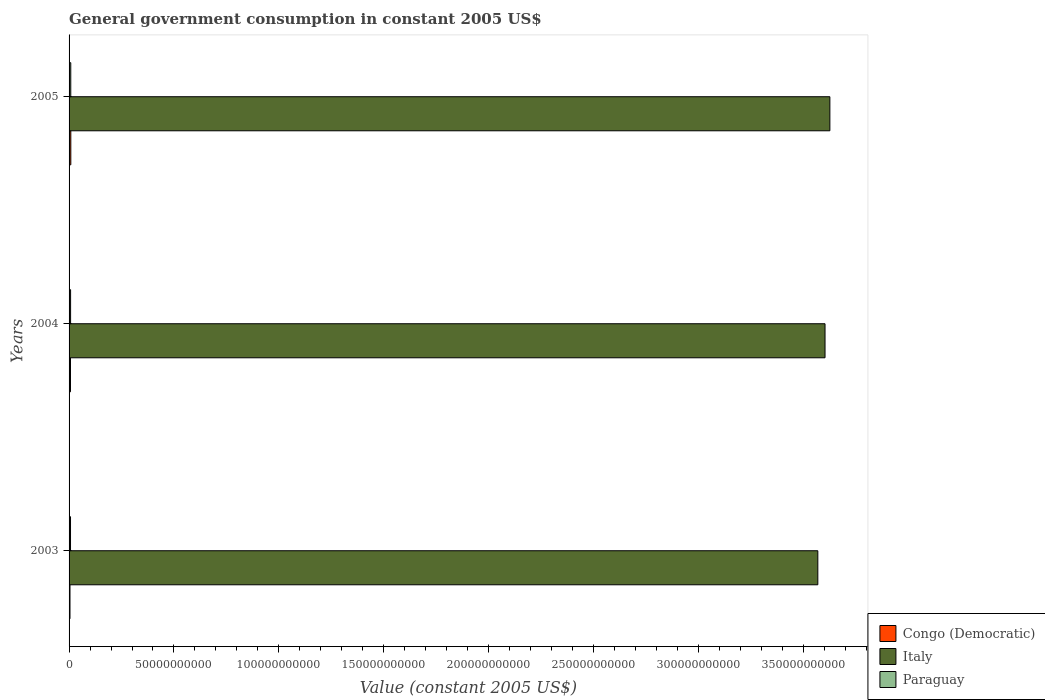What is the government conusmption in Congo (Democratic) in 2004?
Give a very brief answer. 6.73e+08. Across all years, what is the maximum government conusmption in Paraguay?
Your answer should be very brief. 8.11e+08. Across all years, what is the minimum government conusmption in Italy?
Ensure brevity in your answer.  3.57e+11. In which year was the government conusmption in Italy minimum?
Give a very brief answer. 2003. What is the total government conusmption in Congo (Democratic) in the graph?
Your response must be concise. 1.94e+09. What is the difference between the government conusmption in Congo (Democratic) in 2004 and that in 2005?
Ensure brevity in your answer.  -1.58e+08. What is the difference between the government conusmption in Congo (Democratic) in 2004 and the government conusmption in Paraguay in 2005?
Ensure brevity in your answer.  -1.38e+08. What is the average government conusmption in Italy per year?
Provide a succinct answer. 3.60e+11. In the year 2005, what is the difference between the government conusmption in Congo (Democratic) and government conusmption in Paraguay?
Your answer should be very brief. 2.02e+07. In how many years, is the government conusmption in Congo (Democratic) greater than 190000000000 US$?
Give a very brief answer. 0. What is the ratio of the government conusmption in Paraguay in 2003 to that in 2004?
Your answer should be very brief. 0.94. Is the government conusmption in Italy in 2003 less than that in 2004?
Give a very brief answer. Yes. What is the difference between the highest and the second highest government conusmption in Italy?
Offer a very short reply. 2.31e+09. What is the difference between the highest and the lowest government conusmption in Italy?
Make the answer very short. 5.74e+09. In how many years, is the government conusmption in Paraguay greater than the average government conusmption in Paraguay taken over all years?
Your answer should be compact. 1. What does the 1st bar from the top in 2003 represents?
Ensure brevity in your answer.  Paraguay. What does the 2nd bar from the bottom in 2005 represents?
Give a very brief answer. Italy. Is it the case that in every year, the sum of the government conusmption in Paraguay and government conusmption in Italy is greater than the government conusmption in Congo (Democratic)?
Offer a terse response. Yes. Are all the bars in the graph horizontal?
Your answer should be very brief. Yes. How many years are there in the graph?
Give a very brief answer. 3. Does the graph contain any zero values?
Your answer should be very brief. No. Where does the legend appear in the graph?
Ensure brevity in your answer.  Bottom right. What is the title of the graph?
Provide a succinct answer. General government consumption in constant 2005 US$. Does "Liberia" appear as one of the legend labels in the graph?
Offer a very short reply. No. What is the label or title of the X-axis?
Give a very brief answer. Value (constant 2005 US$). What is the label or title of the Y-axis?
Give a very brief answer. Years. What is the Value (constant 2005 US$) in Congo (Democratic) in 2003?
Offer a terse response. 4.39e+08. What is the Value (constant 2005 US$) in Italy in 2003?
Your answer should be compact. 3.57e+11. What is the Value (constant 2005 US$) of Paraguay in 2003?
Ensure brevity in your answer.  6.86e+08. What is the Value (constant 2005 US$) of Congo (Democratic) in 2004?
Provide a short and direct response. 6.73e+08. What is the Value (constant 2005 US$) of Italy in 2004?
Your answer should be very brief. 3.60e+11. What is the Value (constant 2005 US$) in Paraguay in 2004?
Your answer should be compact. 7.28e+08. What is the Value (constant 2005 US$) in Congo (Democratic) in 2005?
Offer a terse response. 8.31e+08. What is the Value (constant 2005 US$) of Italy in 2005?
Make the answer very short. 3.63e+11. What is the Value (constant 2005 US$) in Paraguay in 2005?
Your answer should be very brief. 8.11e+08. Across all years, what is the maximum Value (constant 2005 US$) of Congo (Democratic)?
Your answer should be very brief. 8.31e+08. Across all years, what is the maximum Value (constant 2005 US$) of Italy?
Your response must be concise. 3.63e+11. Across all years, what is the maximum Value (constant 2005 US$) in Paraguay?
Provide a succinct answer. 8.11e+08. Across all years, what is the minimum Value (constant 2005 US$) in Congo (Democratic)?
Ensure brevity in your answer.  4.39e+08. Across all years, what is the minimum Value (constant 2005 US$) in Italy?
Ensure brevity in your answer.  3.57e+11. Across all years, what is the minimum Value (constant 2005 US$) in Paraguay?
Your response must be concise. 6.86e+08. What is the total Value (constant 2005 US$) of Congo (Democratic) in the graph?
Your response must be concise. 1.94e+09. What is the total Value (constant 2005 US$) in Italy in the graph?
Your answer should be compact. 1.08e+12. What is the total Value (constant 2005 US$) in Paraguay in the graph?
Your answer should be compact. 2.22e+09. What is the difference between the Value (constant 2005 US$) of Congo (Democratic) in 2003 and that in 2004?
Provide a short and direct response. -2.34e+08. What is the difference between the Value (constant 2005 US$) of Italy in 2003 and that in 2004?
Offer a terse response. -3.44e+09. What is the difference between the Value (constant 2005 US$) of Paraguay in 2003 and that in 2004?
Make the answer very short. -4.14e+07. What is the difference between the Value (constant 2005 US$) of Congo (Democratic) in 2003 and that in 2005?
Offer a terse response. -3.92e+08. What is the difference between the Value (constant 2005 US$) in Italy in 2003 and that in 2005?
Provide a succinct answer. -5.74e+09. What is the difference between the Value (constant 2005 US$) in Paraguay in 2003 and that in 2005?
Provide a short and direct response. -1.25e+08. What is the difference between the Value (constant 2005 US$) in Congo (Democratic) in 2004 and that in 2005?
Your response must be concise. -1.58e+08. What is the difference between the Value (constant 2005 US$) in Italy in 2004 and that in 2005?
Keep it short and to the point. -2.31e+09. What is the difference between the Value (constant 2005 US$) of Paraguay in 2004 and that in 2005?
Your response must be concise. -8.33e+07. What is the difference between the Value (constant 2005 US$) of Congo (Democratic) in 2003 and the Value (constant 2005 US$) of Italy in 2004?
Make the answer very short. -3.60e+11. What is the difference between the Value (constant 2005 US$) of Congo (Democratic) in 2003 and the Value (constant 2005 US$) of Paraguay in 2004?
Your answer should be compact. -2.89e+08. What is the difference between the Value (constant 2005 US$) in Italy in 2003 and the Value (constant 2005 US$) in Paraguay in 2004?
Offer a terse response. 3.56e+11. What is the difference between the Value (constant 2005 US$) of Congo (Democratic) in 2003 and the Value (constant 2005 US$) of Italy in 2005?
Make the answer very short. -3.62e+11. What is the difference between the Value (constant 2005 US$) of Congo (Democratic) in 2003 and the Value (constant 2005 US$) of Paraguay in 2005?
Make the answer very short. -3.72e+08. What is the difference between the Value (constant 2005 US$) of Italy in 2003 and the Value (constant 2005 US$) of Paraguay in 2005?
Your response must be concise. 3.56e+11. What is the difference between the Value (constant 2005 US$) in Congo (Democratic) in 2004 and the Value (constant 2005 US$) in Italy in 2005?
Your answer should be compact. -3.62e+11. What is the difference between the Value (constant 2005 US$) in Congo (Democratic) in 2004 and the Value (constant 2005 US$) in Paraguay in 2005?
Keep it short and to the point. -1.38e+08. What is the difference between the Value (constant 2005 US$) of Italy in 2004 and the Value (constant 2005 US$) of Paraguay in 2005?
Ensure brevity in your answer.  3.60e+11. What is the average Value (constant 2005 US$) in Congo (Democratic) per year?
Your answer should be compact. 6.48e+08. What is the average Value (constant 2005 US$) of Italy per year?
Your answer should be very brief. 3.60e+11. What is the average Value (constant 2005 US$) of Paraguay per year?
Provide a succinct answer. 7.42e+08. In the year 2003, what is the difference between the Value (constant 2005 US$) in Congo (Democratic) and Value (constant 2005 US$) in Italy?
Provide a short and direct response. -3.56e+11. In the year 2003, what is the difference between the Value (constant 2005 US$) of Congo (Democratic) and Value (constant 2005 US$) of Paraguay?
Ensure brevity in your answer.  -2.47e+08. In the year 2003, what is the difference between the Value (constant 2005 US$) of Italy and Value (constant 2005 US$) of Paraguay?
Provide a succinct answer. 3.56e+11. In the year 2004, what is the difference between the Value (constant 2005 US$) in Congo (Democratic) and Value (constant 2005 US$) in Italy?
Your answer should be very brief. -3.60e+11. In the year 2004, what is the difference between the Value (constant 2005 US$) in Congo (Democratic) and Value (constant 2005 US$) in Paraguay?
Offer a very short reply. -5.45e+07. In the year 2004, what is the difference between the Value (constant 2005 US$) in Italy and Value (constant 2005 US$) in Paraguay?
Offer a very short reply. 3.60e+11. In the year 2005, what is the difference between the Value (constant 2005 US$) in Congo (Democratic) and Value (constant 2005 US$) in Italy?
Provide a succinct answer. -3.62e+11. In the year 2005, what is the difference between the Value (constant 2005 US$) of Congo (Democratic) and Value (constant 2005 US$) of Paraguay?
Ensure brevity in your answer.  2.02e+07. In the year 2005, what is the difference between the Value (constant 2005 US$) in Italy and Value (constant 2005 US$) in Paraguay?
Offer a terse response. 3.62e+11. What is the ratio of the Value (constant 2005 US$) of Congo (Democratic) in 2003 to that in 2004?
Provide a short and direct response. 0.65. What is the ratio of the Value (constant 2005 US$) in Italy in 2003 to that in 2004?
Your answer should be very brief. 0.99. What is the ratio of the Value (constant 2005 US$) in Paraguay in 2003 to that in 2004?
Give a very brief answer. 0.94. What is the ratio of the Value (constant 2005 US$) of Congo (Democratic) in 2003 to that in 2005?
Ensure brevity in your answer.  0.53. What is the ratio of the Value (constant 2005 US$) of Italy in 2003 to that in 2005?
Ensure brevity in your answer.  0.98. What is the ratio of the Value (constant 2005 US$) in Paraguay in 2003 to that in 2005?
Offer a terse response. 0.85. What is the ratio of the Value (constant 2005 US$) in Congo (Democratic) in 2004 to that in 2005?
Ensure brevity in your answer.  0.81. What is the ratio of the Value (constant 2005 US$) of Paraguay in 2004 to that in 2005?
Offer a terse response. 0.9. What is the difference between the highest and the second highest Value (constant 2005 US$) in Congo (Democratic)?
Provide a short and direct response. 1.58e+08. What is the difference between the highest and the second highest Value (constant 2005 US$) in Italy?
Your response must be concise. 2.31e+09. What is the difference between the highest and the second highest Value (constant 2005 US$) in Paraguay?
Provide a short and direct response. 8.33e+07. What is the difference between the highest and the lowest Value (constant 2005 US$) in Congo (Democratic)?
Offer a terse response. 3.92e+08. What is the difference between the highest and the lowest Value (constant 2005 US$) of Italy?
Make the answer very short. 5.74e+09. What is the difference between the highest and the lowest Value (constant 2005 US$) in Paraguay?
Your response must be concise. 1.25e+08. 